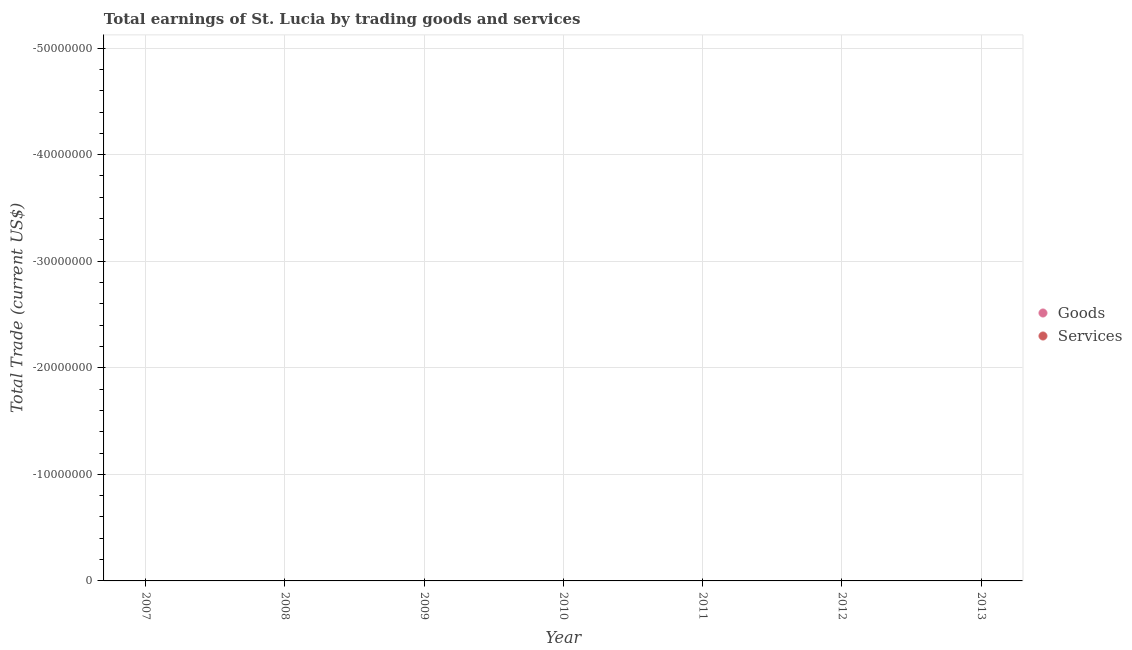How many different coloured dotlines are there?
Ensure brevity in your answer.  0. What is the total amount earned by trading goods in the graph?
Your answer should be very brief. 0. In how many years, is the amount earned by trading services greater than -28000000 US$?
Ensure brevity in your answer.  0. Does the amount earned by trading services monotonically increase over the years?
Offer a terse response. No. Is the amount earned by trading goods strictly less than the amount earned by trading services over the years?
Provide a succinct answer. Yes. How many dotlines are there?
Offer a very short reply. 0. Does the graph contain any zero values?
Give a very brief answer. Yes. Where does the legend appear in the graph?
Your response must be concise. Center right. What is the title of the graph?
Your answer should be compact. Total earnings of St. Lucia by trading goods and services. Does "External balance on goods" appear as one of the legend labels in the graph?
Your answer should be very brief. No. What is the label or title of the Y-axis?
Your answer should be very brief. Total Trade (current US$). What is the Total Trade (current US$) of Goods in 2009?
Provide a succinct answer. 0. What is the Total Trade (current US$) of Services in 2009?
Keep it short and to the point. 0. What is the Total Trade (current US$) of Goods in 2011?
Offer a very short reply. 0. What is the Total Trade (current US$) of Services in 2011?
Offer a terse response. 0. What is the Total Trade (current US$) of Services in 2013?
Keep it short and to the point. 0. What is the total Total Trade (current US$) in Goods in the graph?
Keep it short and to the point. 0. What is the average Total Trade (current US$) of Goods per year?
Your response must be concise. 0. What is the average Total Trade (current US$) in Services per year?
Give a very brief answer. 0. 